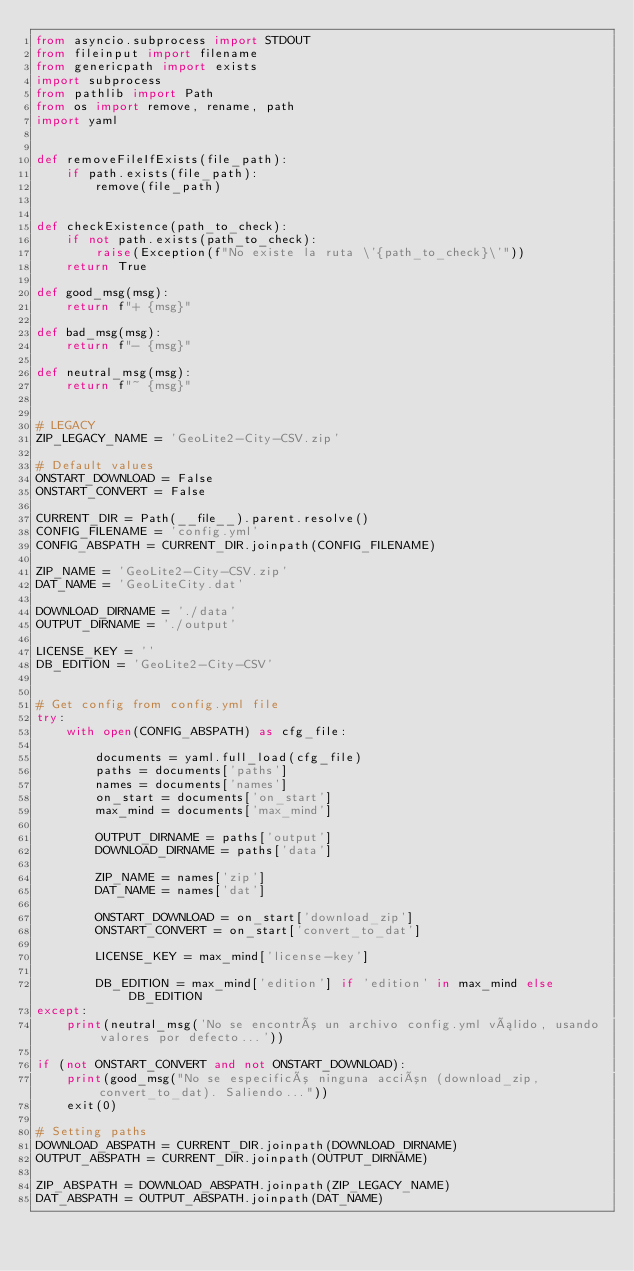Convert code to text. <code><loc_0><loc_0><loc_500><loc_500><_Python_>from asyncio.subprocess import STDOUT
from fileinput import filename
from genericpath import exists
import subprocess
from pathlib import Path
from os import remove, rename, path
import yaml


def removeFileIfExists(file_path):
    if path.exists(file_path):
        remove(file_path)


def checkExistence(path_to_check):
    if not path.exists(path_to_check):
        raise(Exception(f"No existe la ruta \'{path_to_check}\'"))
    return True

def good_msg(msg):
    return f"+ {msg}"

def bad_msg(msg):
    return f"- {msg}"

def neutral_msg(msg):
    return f"~ {msg}"


# LEGACY
ZIP_LEGACY_NAME = 'GeoLite2-City-CSV.zip'

# Default values
ONSTART_DOWNLOAD = False
ONSTART_CONVERT = False

CURRENT_DIR = Path(__file__).parent.resolve()
CONFIG_FILENAME = 'config.yml'
CONFIG_ABSPATH = CURRENT_DIR.joinpath(CONFIG_FILENAME)

ZIP_NAME = 'GeoLite2-City-CSV.zip'
DAT_NAME = 'GeoLiteCity.dat'

DOWNLOAD_DIRNAME = './data'
OUTPUT_DIRNAME = './output'

LICENSE_KEY = ''
DB_EDITION = 'GeoLite2-City-CSV'


# Get config from config.yml file
try:
    with open(CONFIG_ABSPATH) as cfg_file:

        documents = yaml.full_load(cfg_file)
        paths = documents['paths']
        names = documents['names']
        on_start = documents['on_start']
        max_mind = documents['max_mind']

        OUTPUT_DIRNAME = paths['output']
        DOWNLOAD_DIRNAME = paths['data']

        ZIP_NAME = names['zip']
        DAT_NAME = names['dat']

        ONSTART_DOWNLOAD = on_start['download_zip']
        ONSTART_CONVERT = on_start['convert_to_dat']

        LICENSE_KEY = max_mind['license-key']
        
        DB_EDITION = max_mind['edition'] if 'edition' in max_mind else DB_EDITION 
except:
    print(neutral_msg('No se encontró un archivo config.yml válido, usando valores por defecto...'))

if (not ONSTART_CONVERT and not ONSTART_DOWNLOAD):
    print(good_msg("No se especificó ninguna acción (download_zip, convert_to_dat). Saliendo..."))
    exit(0)

# Setting paths
DOWNLOAD_ABSPATH = CURRENT_DIR.joinpath(DOWNLOAD_DIRNAME)
OUTPUT_ABSPATH = CURRENT_DIR.joinpath(OUTPUT_DIRNAME)

ZIP_ABSPATH = DOWNLOAD_ABSPATH.joinpath(ZIP_LEGACY_NAME)
DAT_ABSPATH = OUTPUT_ABSPATH.joinpath(DAT_NAME)

</code> 